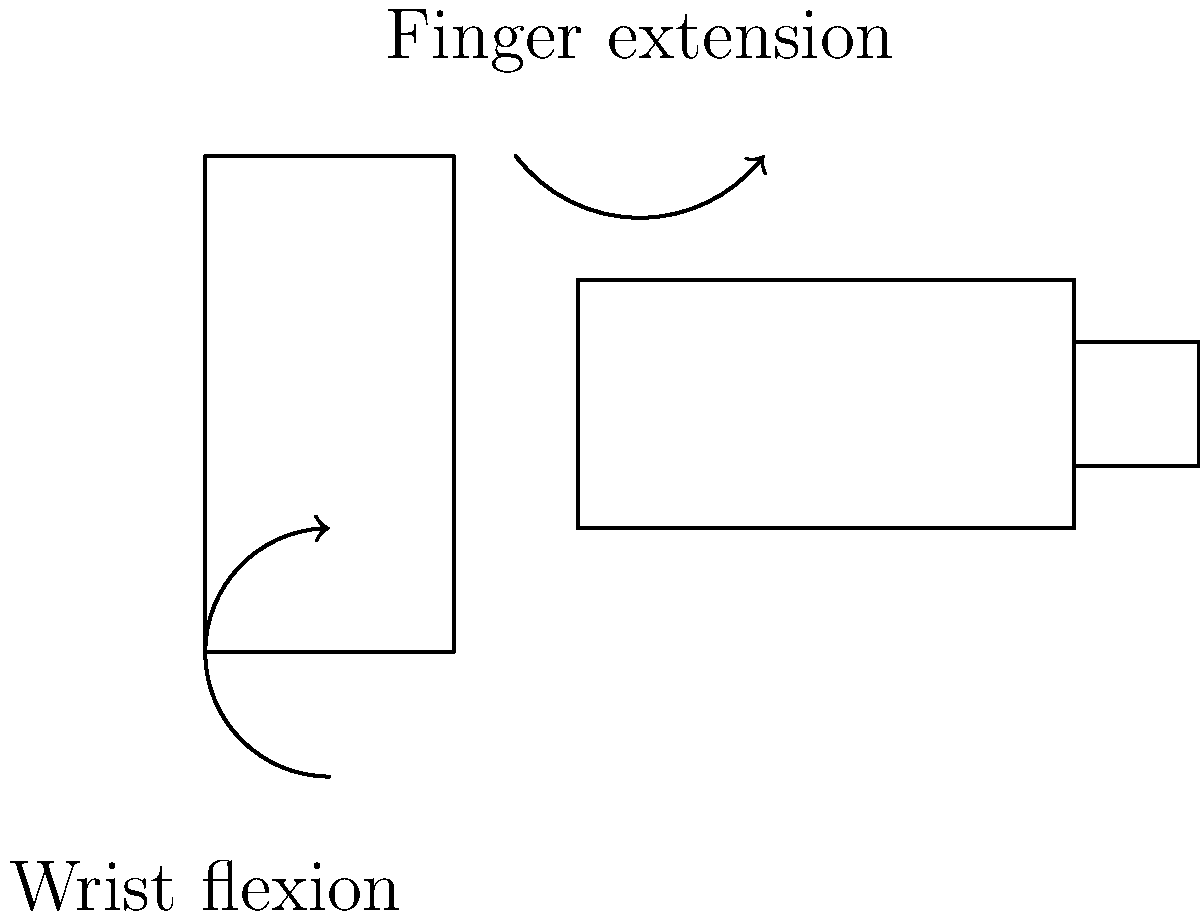When adjusting the camera's shutter speed dial, which combination of biomechanical movements in the wrist and fingers is most likely to occur? To answer this question, let's break down the biomechanics of adjusting a camera's shutter speed dial:

1. Wrist movement:
   - The wrist typically undergoes a slight flexion (bending towards the palm) to position the hand for optimal control of the camera.
   - This flexion allows for better stability and precision when manipulating small dials.

2. Finger movement:
   - The index finger and thumb are primarily involved in adjusting the shutter speed dial.
   - The index finger often extends (straightens) to reach the dial.
   - The thumb may oppose the index finger to provide counter-pressure and stability.

3. Combined movement:
   - As the photographer adjusts the dial, there's a coordinated action between the wrist and fingers.
   - The wrist maintains a slightly flexed position for stability.
   - The index finger extends to reach and turn the dial, while other fingers may curl slightly to maintain grip on the camera body.

4. Fine motor control:
   - Adjusting the shutter speed requires precise movements, engaging the intrinsic muscles of the hand for fine motor control.
   - This action involves a combination of finger extension and flexion in small, controlled movements.

Given these biomechanical considerations, the most likely combination of movements when adjusting the shutter speed dial would be wrist flexion and finger extension.
Answer: Wrist flexion and finger extension 